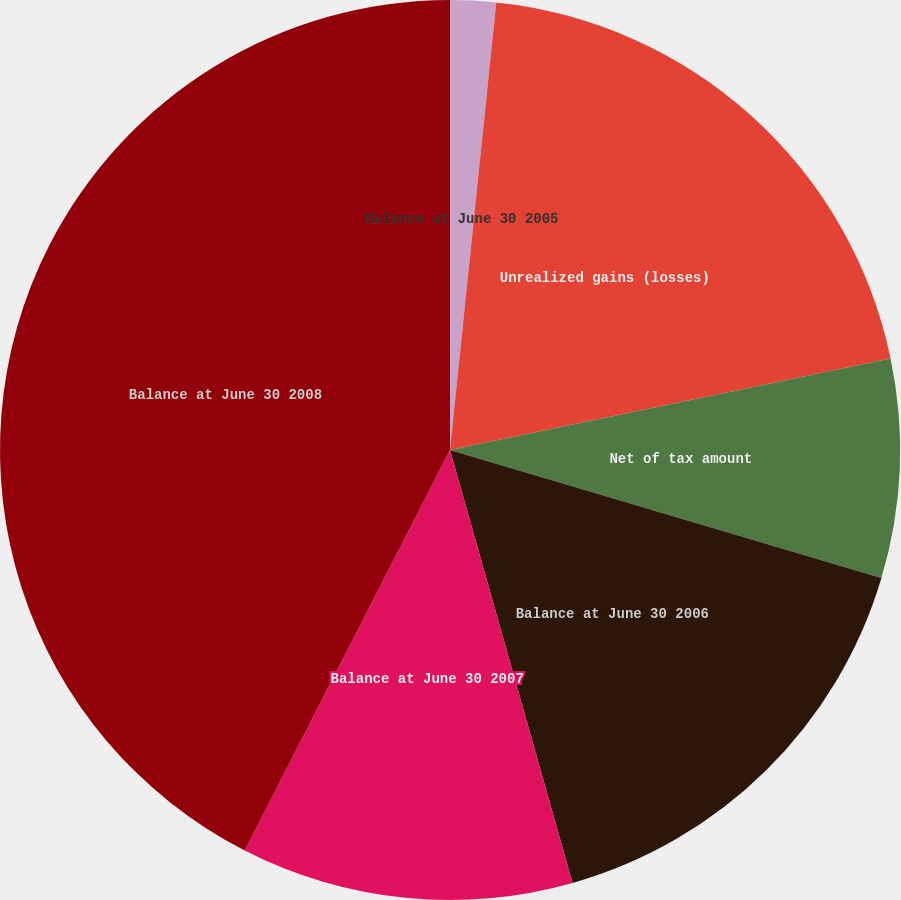Convert chart to OTSL. <chart><loc_0><loc_0><loc_500><loc_500><pie_chart><fcel>Balance at June 30 2005<fcel>Unrealized gains (losses)<fcel>Net of tax amount<fcel>Balance at June 30 2006<fcel>Balance at June 30 2007<fcel>Balance at June 30 2008<nl><fcel>1.64%<fcel>20.1%<fcel>7.85%<fcel>16.02%<fcel>11.93%<fcel>42.46%<nl></chart> 